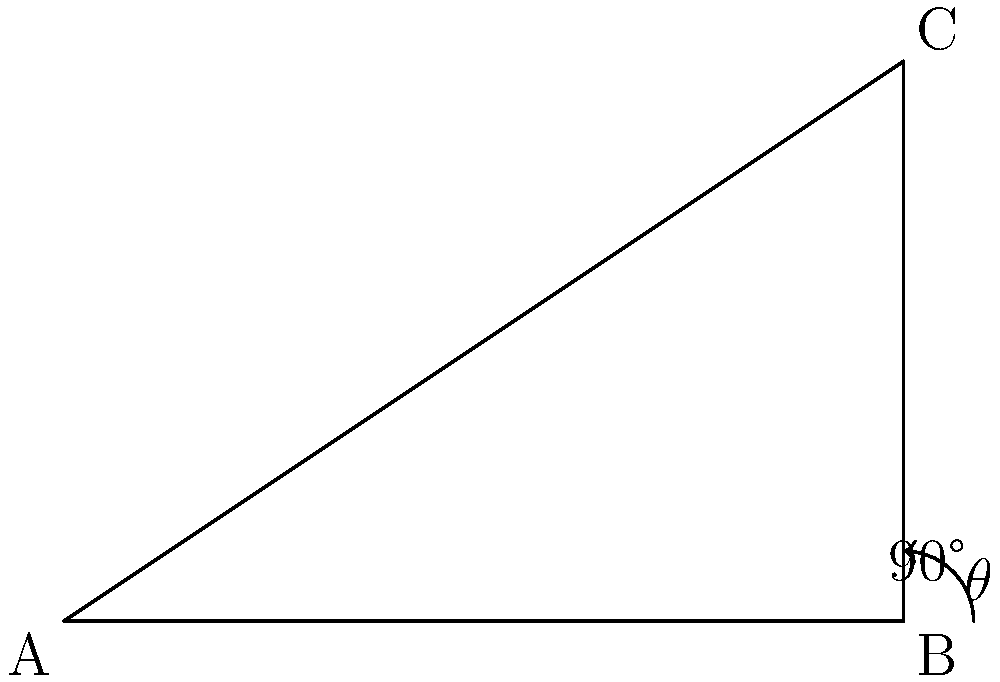In your study, you've arranged two bookshelves in an L-shape. The first shelf extends 6 feet from the corner, while the second shelf extends 4 feet perpendicular to the first. What is the measure of the angle $\theta$ between these two bookshelves? Let's approach this step-by-step:

1) The bookshelves form a right triangle, with the corner being the right angle (90°).

2) We know two sides of this triangle:
   - The adjacent side (first bookshelf) is 6 feet
   - The opposite side (second bookshelf) is 4 feet

3) To find the angle $\theta$, we can use the tangent function:

   $\tan(\theta) = \frac{\text{opposite}}{\text{adjacent}} = \frac{4}{6} = \frac{2}{3}$

4) To get $\theta$, we need to take the inverse tangent (arctan or $\tan^{-1}$):

   $\theta = \tan^{-1}(\frac{2}{3})$

5) Using a calculator or trigonometric tables:

   $\theta \approx 33.69°$

6) Rounding to the nearest degree:

   $\theta \approx 34°$

This angle represents the measure between the first bookshelf and the hypotenuse of the triangle formed by the two bookshelves.
Answer: $34°$ 